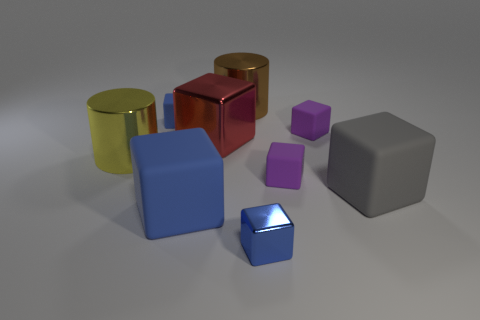Subtract all big red shiny blocks. How many blocks are left? 6 Subtract all cyan cylinders. How many blue blocks are left? 3 Subtract all red cubes. How many cubes are left? 6 Subtract all cylinders. How many objects are left? 7 Add 5 large red metal objects. How many large red metal objects exist? 6 Subtract 0 brown blocks. How many objects are left? 9 Subtract all gray cubes. Subtract all blue spheres. How many cubes are left? 6 Subtract all small cyan matte spheres. Subtract all yellow metal objects. How many objects are left? 8 Add 3 cubes. How many cubes are left? 10 